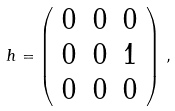Convert formula to latex. <formula><loc_0><loc_0><loc_500><loc_500>h = \left ( \begin{array} { c c c } 0 & 0 & 0 \\ 0 & 0 & 1 \\ 0 & 0 & 0 \end{array} \right ) \, ,</formula> 